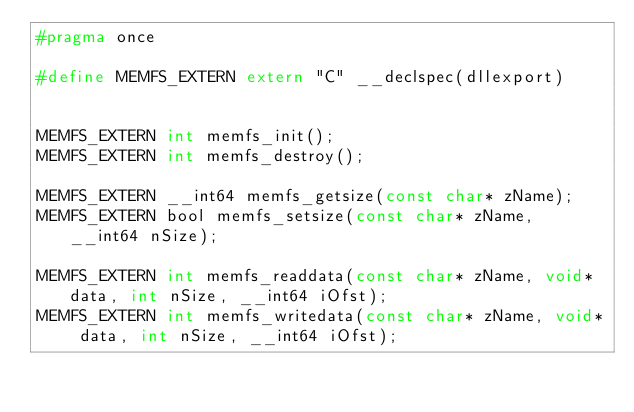<code> <loc_0><loc_0><loc_500><loc_500><_C_>#pragma once

#define MEMFS_EXTERN extern "C" __declspec(dllexport)


MEMFS_EXTERN int memfs_init();
MEMFS_EXTERN int memfs_destroy();

MEMFS_EXTERN __int64 memfs_getsize(const char* zName);
MEMFS_EXTERN bool memfs_setsize(const char* zName, __int64 nSize);

MEMFS_EXTERN int memfs_readdata(const char* zName, void* data, int nSize, __int64 iOfst);
MEMFS_EXTERN int memfs_writedata(const char* zName, void* data, int nSize, __int64 iOfst);
</code> 